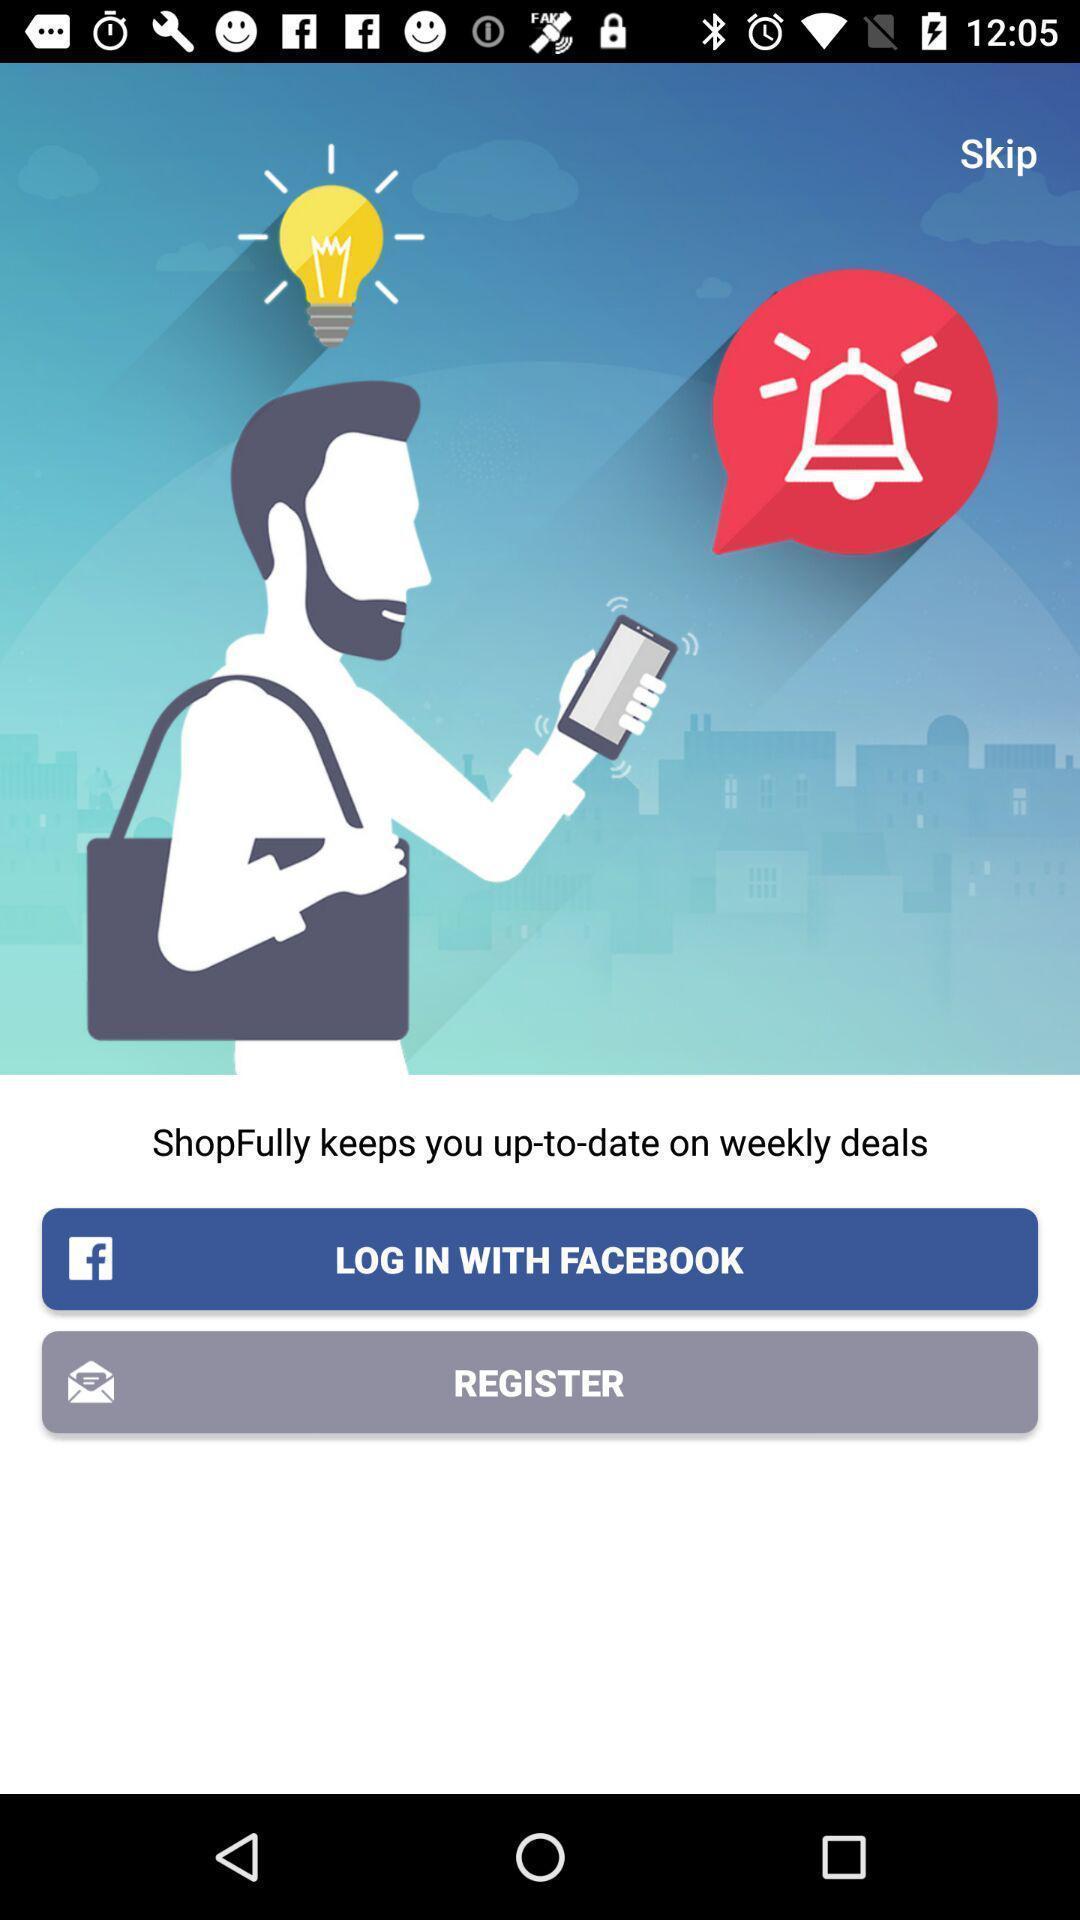What is the overall content of this screenshot? Page asking to login with social app. 